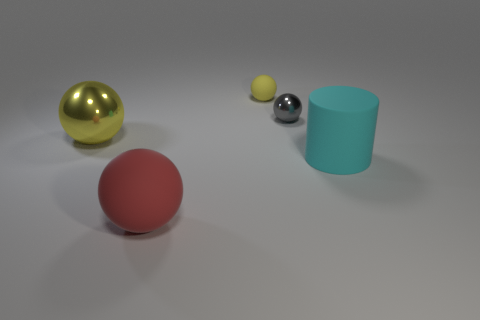Subtract all gray balls. How many balls are left? 3 Subtract all brown cylinders. How many yellow spheres are left? 2 Add 2 large cyan metallic blocks. How many objects exist? 7 Subtract all cylinders. How many objects are left? 4 Subtract all gray spheres. How many spheres are left? 3 Subtract 1 spheres. How many spheres are left? 3 Subtract all yellow spheres. Subtract all large cyan things. How many objects are left? 2 Add 4 gray objects. How many gray objects are left? 5 Add 5 blue rubber cylinders. How many blue rubber cylinders exist? 5 Subtract 0 green blocks. How many objects are left? 5 